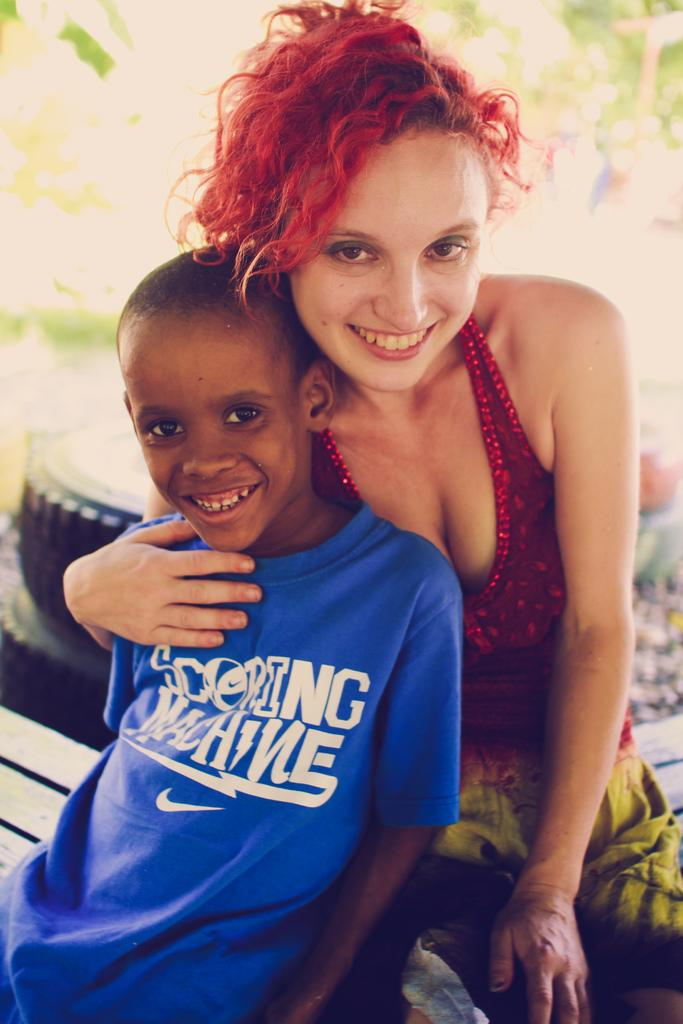Who is present in the image? There is a kid and a lady in the image. What are they doing in the image? The kid and the lady are sitting on a wooden desk. What can be seen in the background of the image? There are tyres in the background of the image. How would you describe the background of the image? The background of the image is blurred. Can you see any geese flying through the rainstorm in the image? There is no rainstorm or geese present in the image. What type of worm can be seen crawling on the wooden desk? There is no worm visible on the wooden desk in the image. 